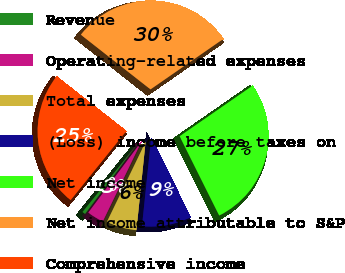Convert chart to OTSL. <chart><loc_0><loc_0><loc_500><loc_500><pie_chart><fcel>Revenue<fcel>Operating-related expenses<fcel>Total expenses<fcel>(Loss) income before taxes on<fcel>Net income<fcel>Net income attributable to S&P<fcel>Comprehensive income<nl><fcel>0.57%<fcel>3.05%<fcel>5.53%<fcel>9.01%<fcel>27.28%<fcel>29.76%<fcel>24.79%<nl></chart> 